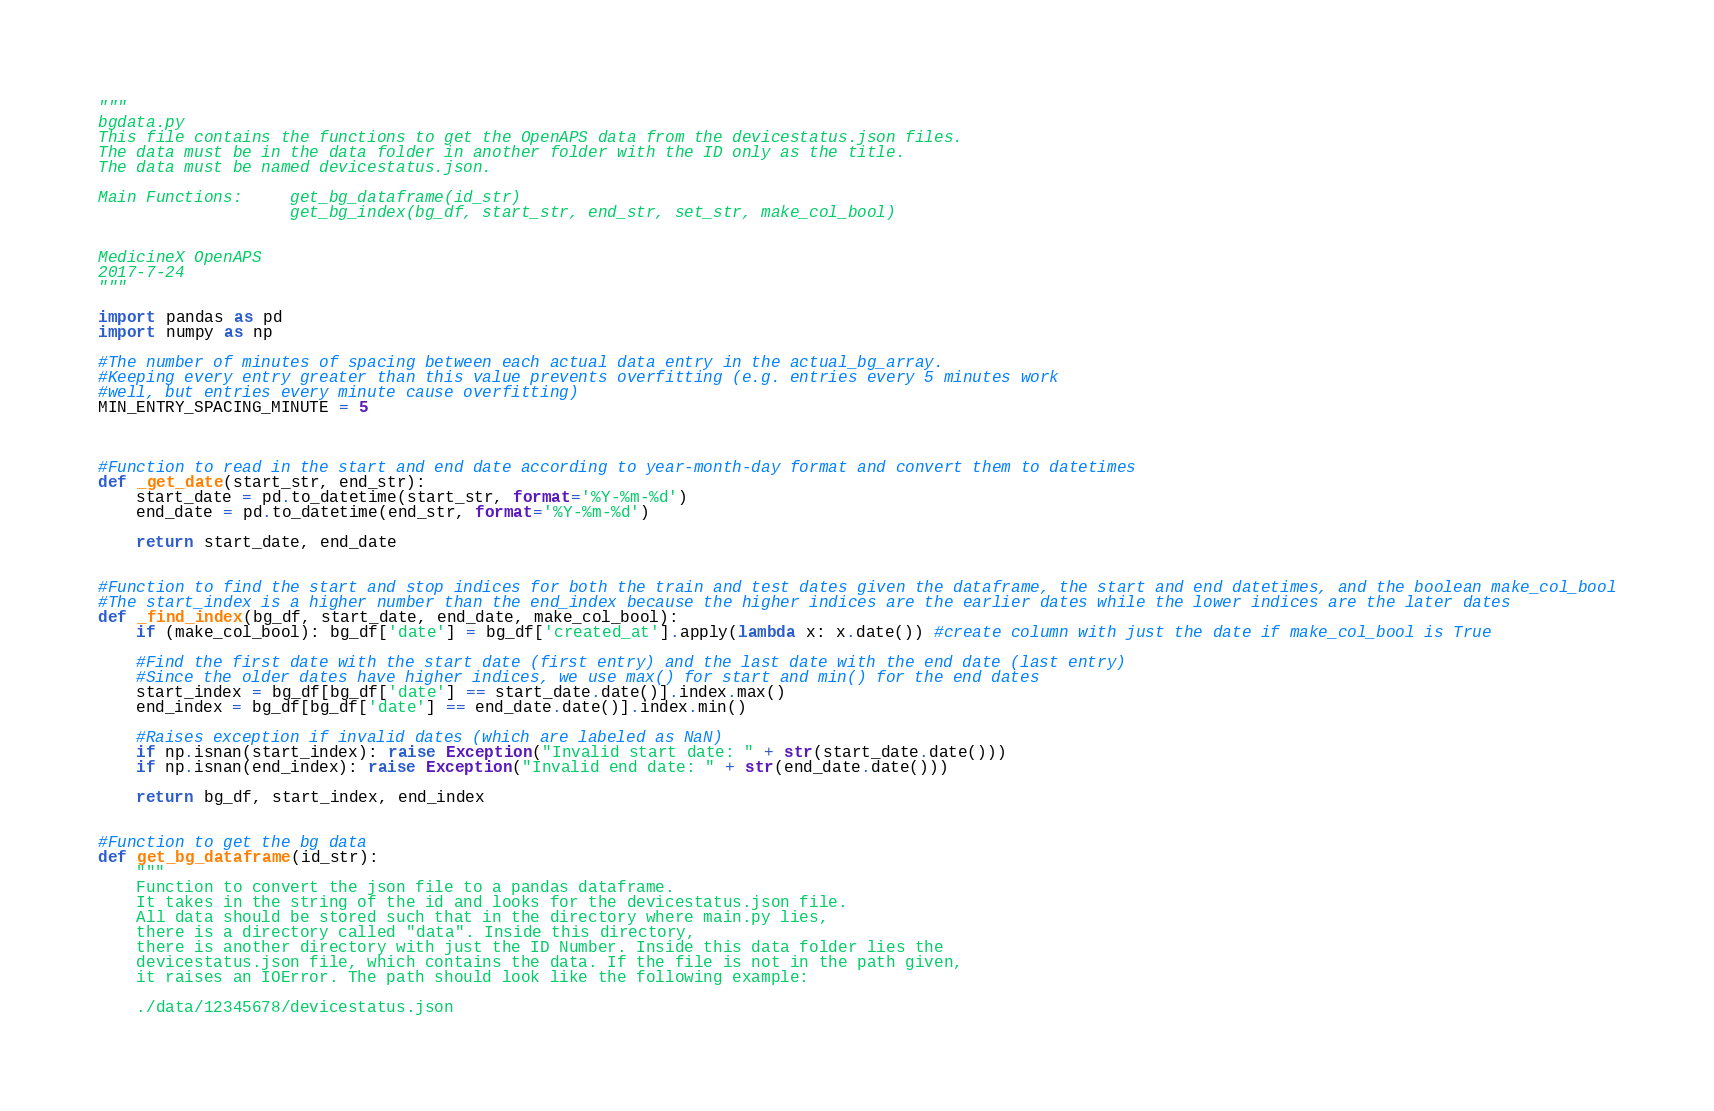Convert code to text. <code><loc_0><loc_0><loc_500><loc_500><_Python_>"""
bgdata.py
This file contains the functions to get the OpenAPS data from the devicestatus.json files.
The data must be in the data folder in another folder with the ID only as the title.
The data must be named devicestatus.json.

Main Functions:     get_bg_dataframe(id_str)
                    get_bg_index(bg_df, start_str, end_str, set_str, make_col_bool)


MedicineX OpenAPS
2017-7-24
"""

import pandas as pd
import numpy as np

#The number of minutes of spacing between each actual data entry in the actual_bg_array.
#Keeping every entry greater than this value prevents overfitting (e.g. entries every 5 minutes work
#well, but entries every minute cause overfitting)
MIN_ENTRY_SPACING_MINUTE = 5



#Function to read in the start and end date according to year-month-day format and convert them to datetimes
def _get_date(start_str, end_str):
    start_date = pd.to_datetime(start_str, format='%Y-%m-%d')
    end_date = pd.to_datetime(end_str, format='%Y-%m-%d')

    return start_date, end_date


#Function to find the start and stop indices for both the train and test dates given the dataframe, the start and end datetimes, and the boolean make_col_bool
#The start_index is a higher number than the end_index because the higher indices are the earlier dates while the lower indices are the later dates
def _find_index(bg_df, start_date, end_date, make_col_bool):
    if (make_col_bool): bg_df['date'] = bg_df['created_at'].apply(lambda x: x.date()) #create column with just the date if make_col_bool is True

    #Find the first date with the start date (first entry) and the last date with the end date (last entry)
    #Since the older dates have higher indices, we use max() for start and min() for the end dates
    start_index = bg_df[bg_df['date'] == start_date.date()].index.max()
    end_index = bg_df[bg_df['date'] == end_date.date()].index.min()

    #Raises exception if invalid dates (which are labeled as NaN)
    if np.isnan(start_index): raise Exception("Invalid start date: " + str(start_date.date()))
    if np.isnan(end_index): raise Exception("Invalid end date: " + str(end_date.date()))

    return bg_df, start_index, end_index


#Function to get the bg data
def get_bg_dataframe(id_str):
    """
    Function to convert the json file to a pandas dataframe.
    It takes in the string of the id and looks for the devicestatus.json file.
    All data should be stored such that in the directory where main.py lies,
    there is a directory called "data". Inside this directory,
    there is another directory with just the ID Number. Inside this data folder lies the
    devicestatus.json file, which contains the data. If the file is not in the path given,
    it raises an IOError. The path should look like the following example:

    ./data/12345678/devicestatus.json
</code> 